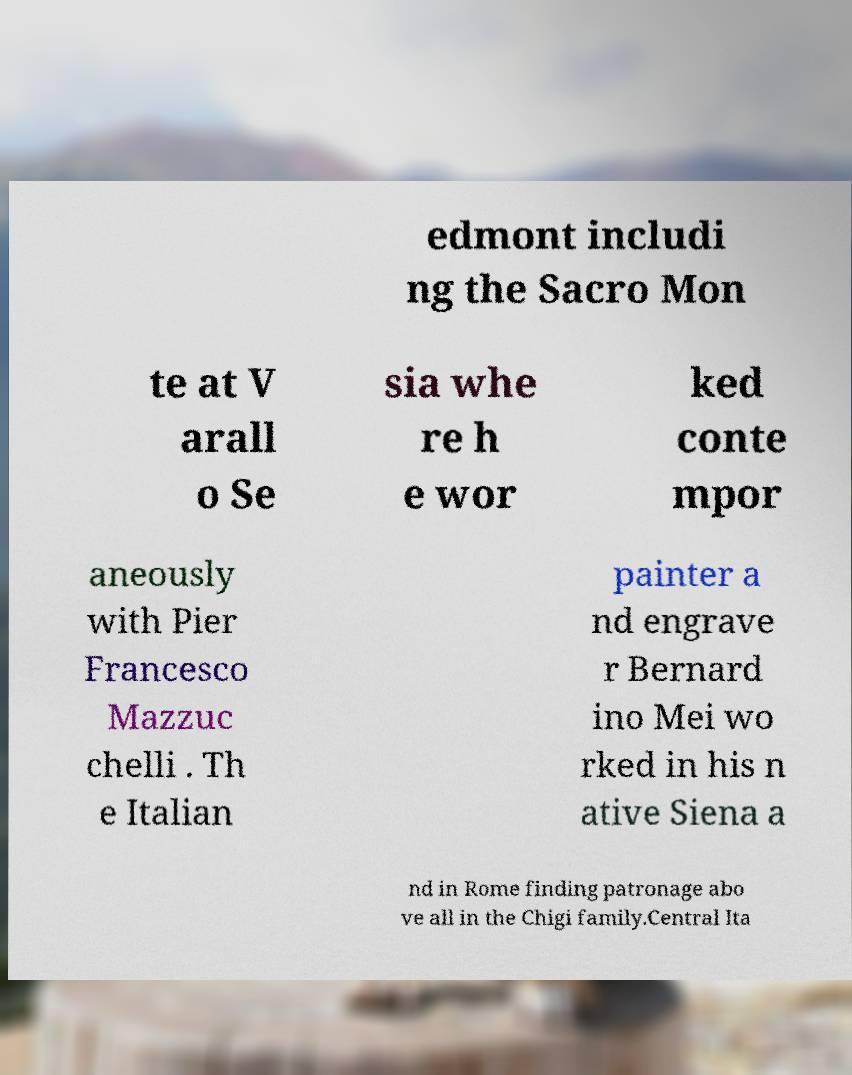I need the written content from this picture converted into text. Can you do that? edmont includi ng the Sacro Mon te at V arall o Se sia whe re h e wor ked conte mpor aneously with Pier Francesco Mazzuc chelli . Th e Italian painter a nd engrave r Bernard ino Mei wo rked in his n ative Siena a nd in Rome finding patronage abo ve all in the Chigi family.Central Ita 